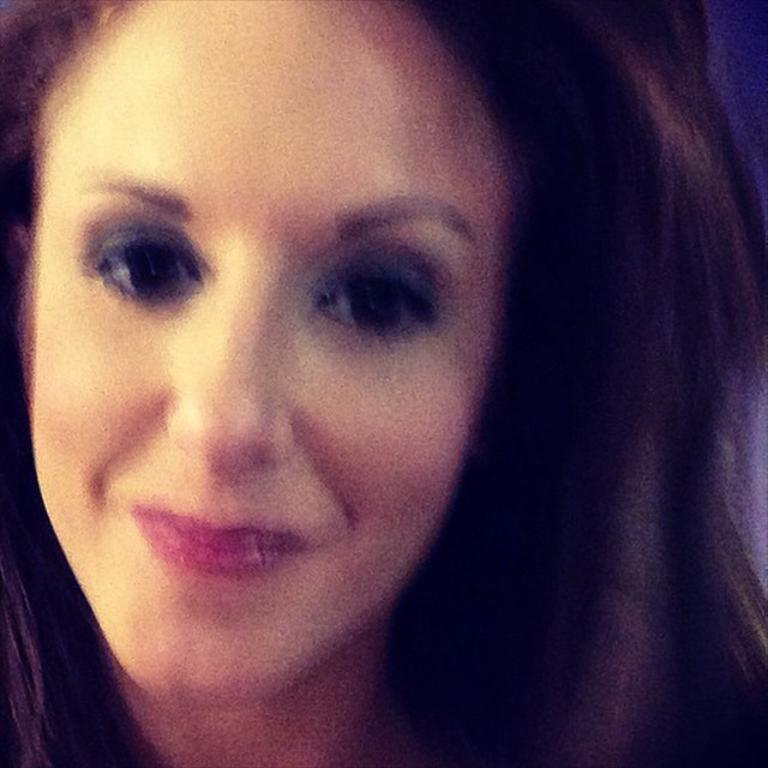Who is the main subject in the foreground of the image? There is a woman in the foreground of the image. What historical event is the beggar referring to in the image? There is no beggar present in the image, and therefore no reference to any historical event can be made. 